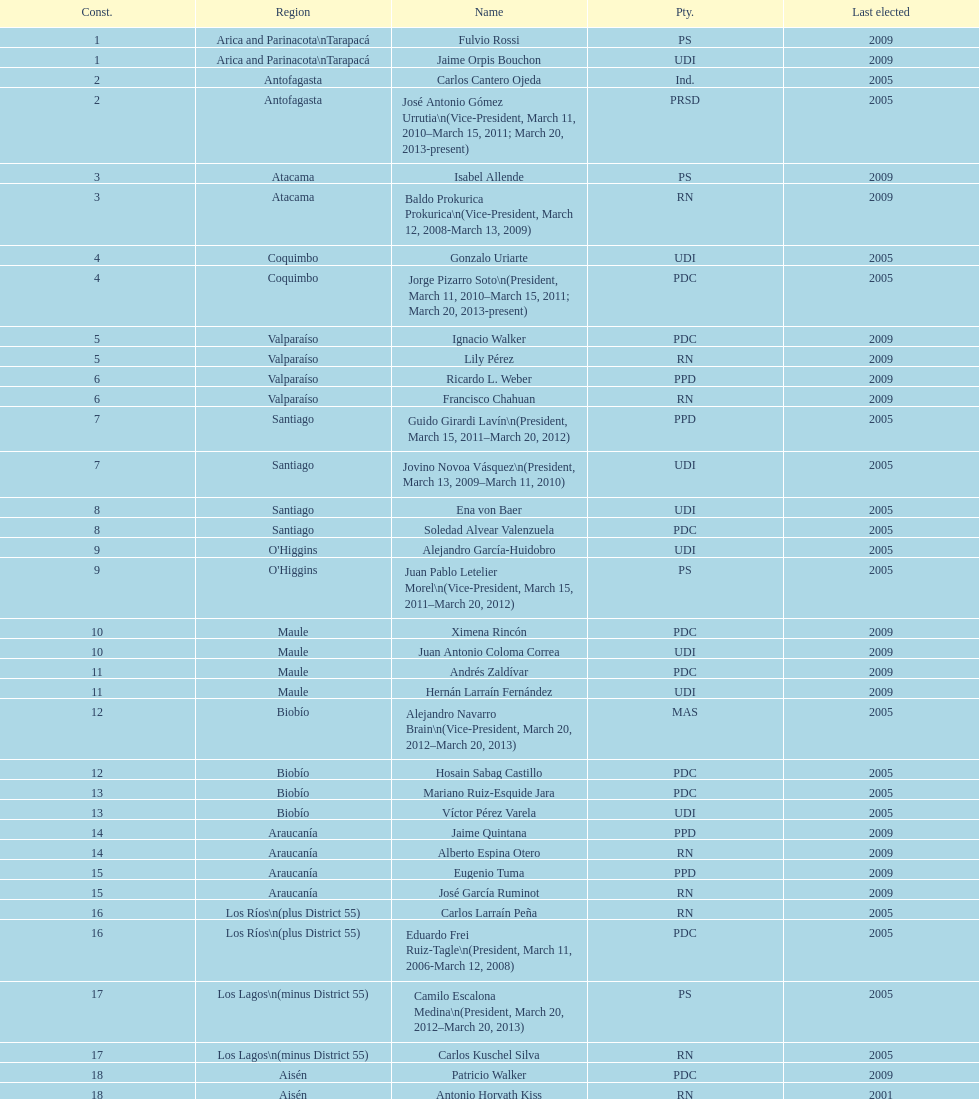What is the difference in years between constiuency 1 and 2? 4 years. 